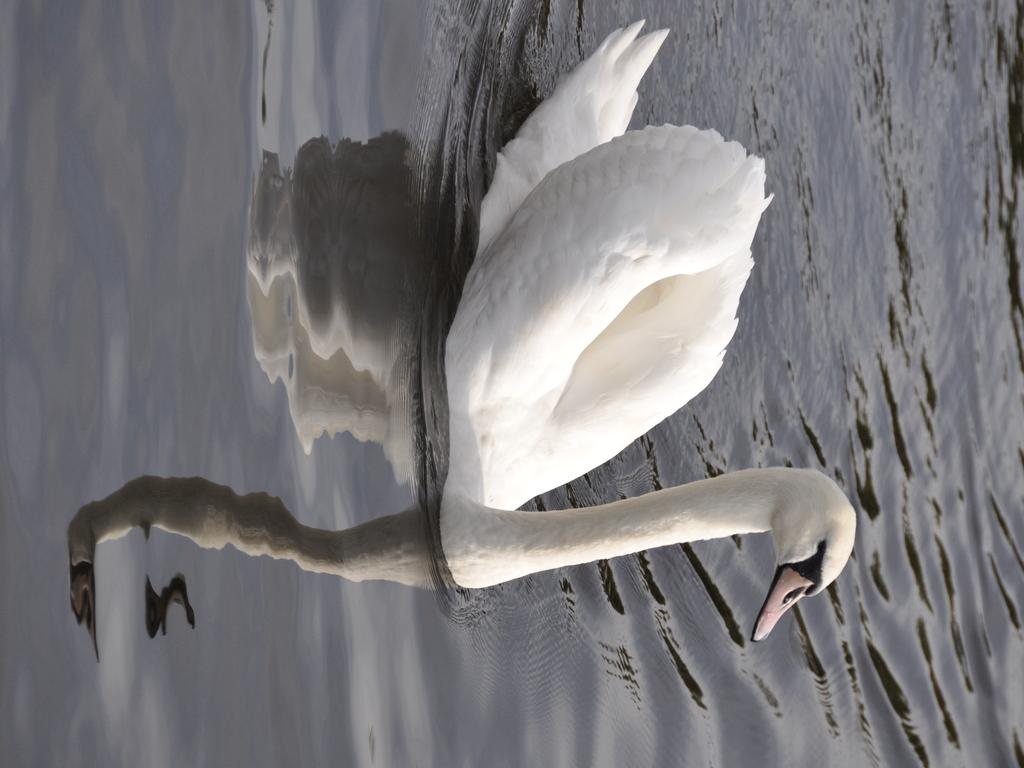What type of animal is in the image? There is a white duck in the image. Where is the duck located in the image? The duck is sitting on the water. What can be seen in the sky in the image? There are clouds in the sky. What is visible in the water in the image? The reflection of the duck and the sky can be seen in the water. Is the farmer holding a gun while feeding the pig in the image? There is no farmer or pig present in the image; it features a white duck sitting on the water. 